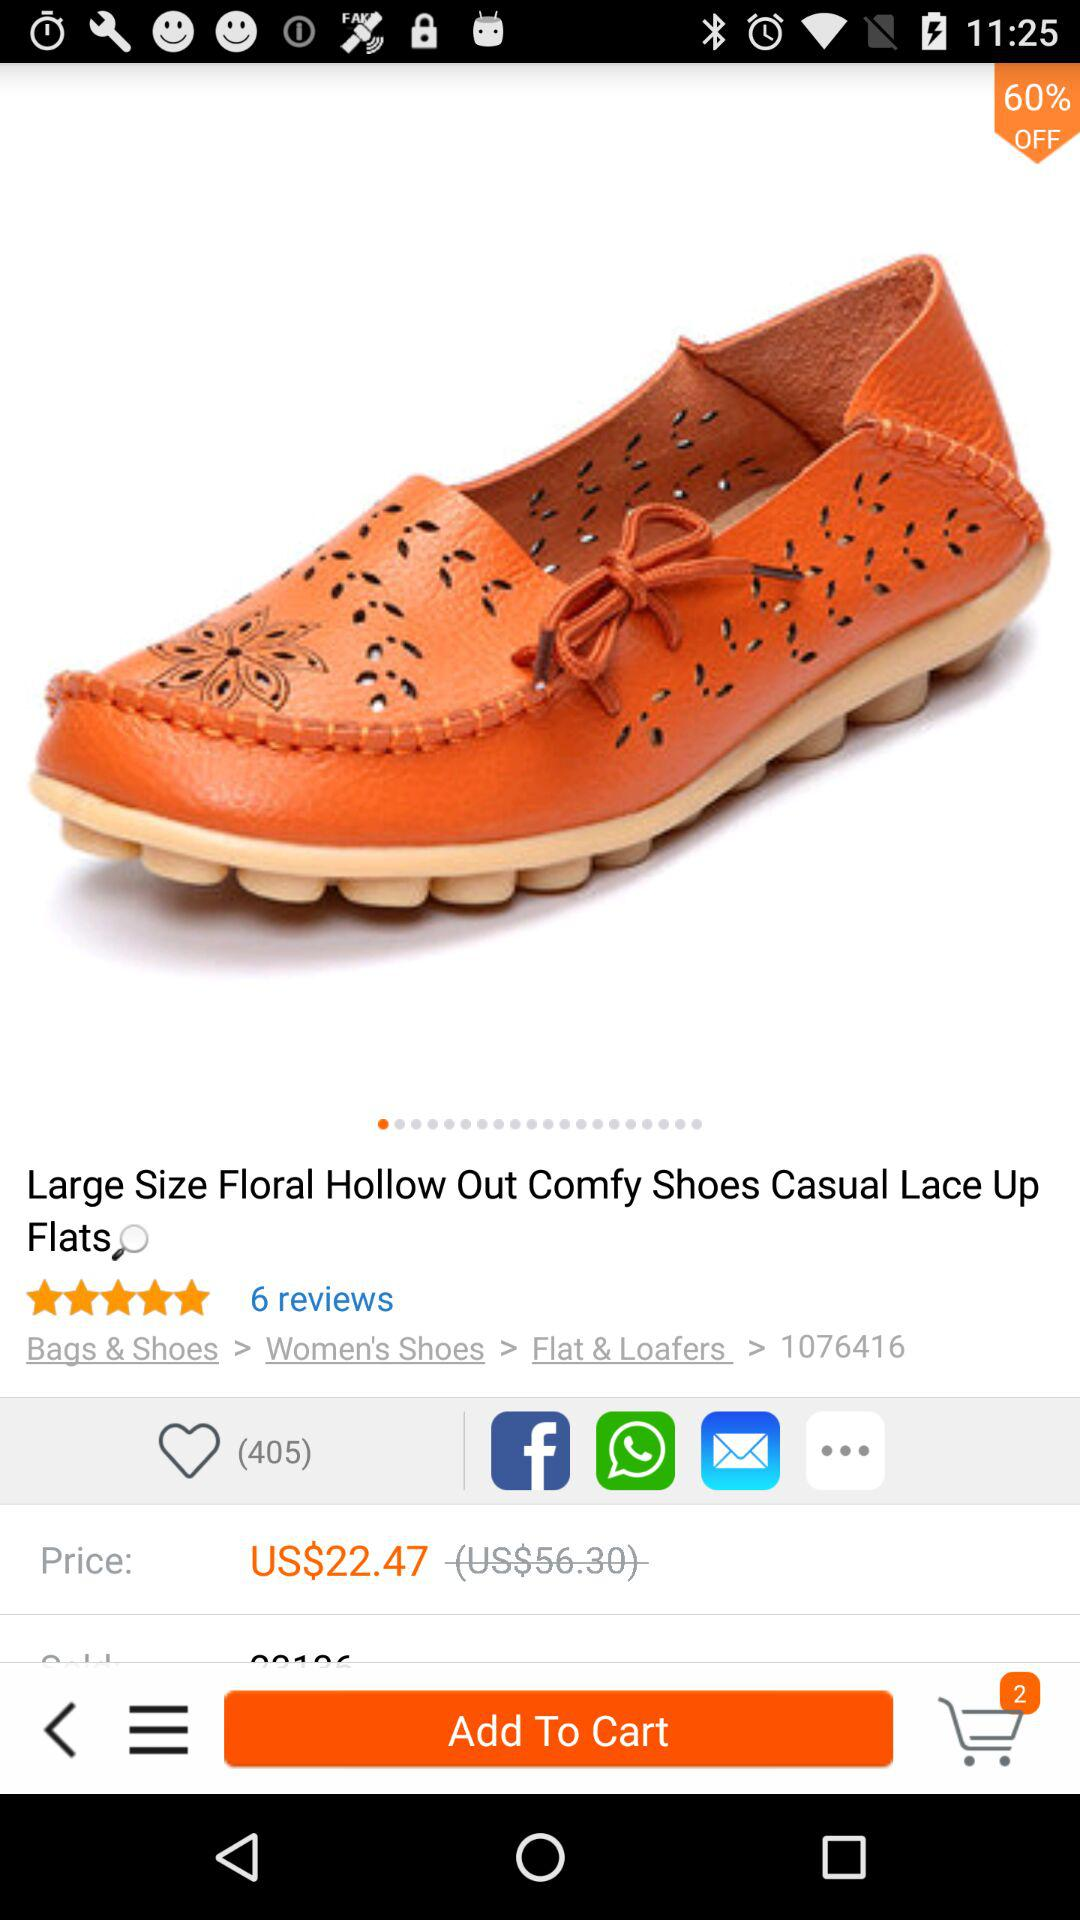How many stars are given to casual lace-up flats? There are 5 stars. 